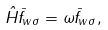Convert formula to latex. <formula><loc_0><loc_0><loc_500><loc_500>\hat { H } \bar { f } _ { w \sigma } = \omega \bar { f } _ { w \sigma } ,</formula> 